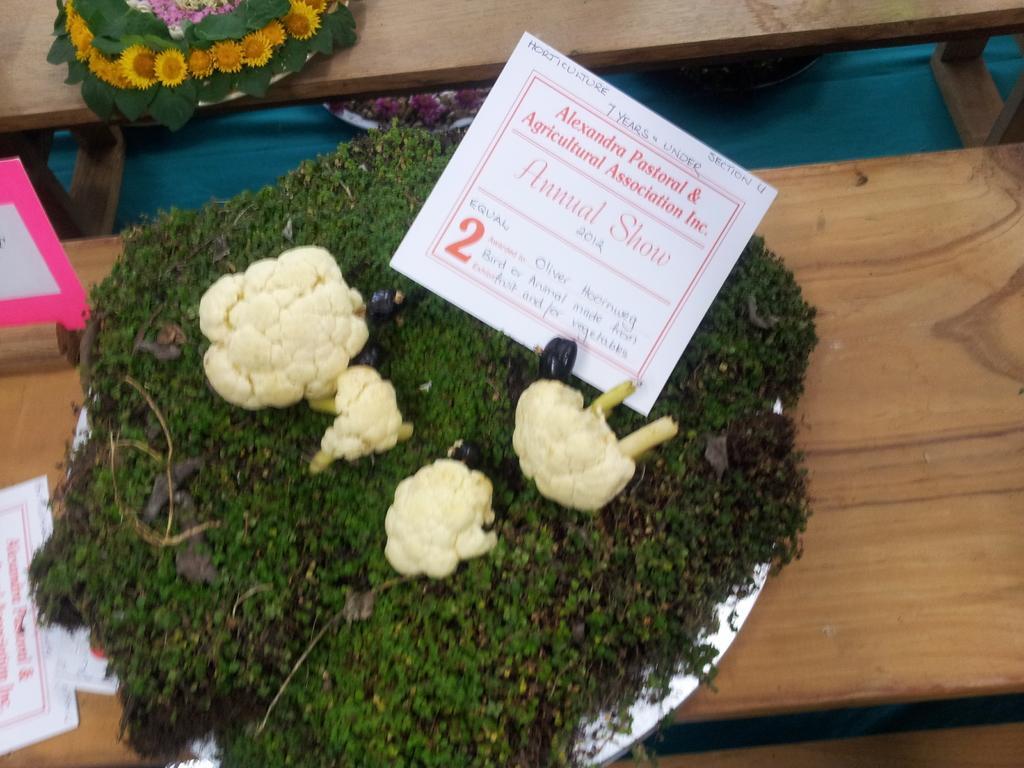Could you give a brief overview of what you see in this image? In this picture there is a plate in he center of the image, which contains greenery, cabbage, and Brinjal on it, there are pamphlets on the left side of the image and there are flowers at the top side of the image, which are placed on the table. 